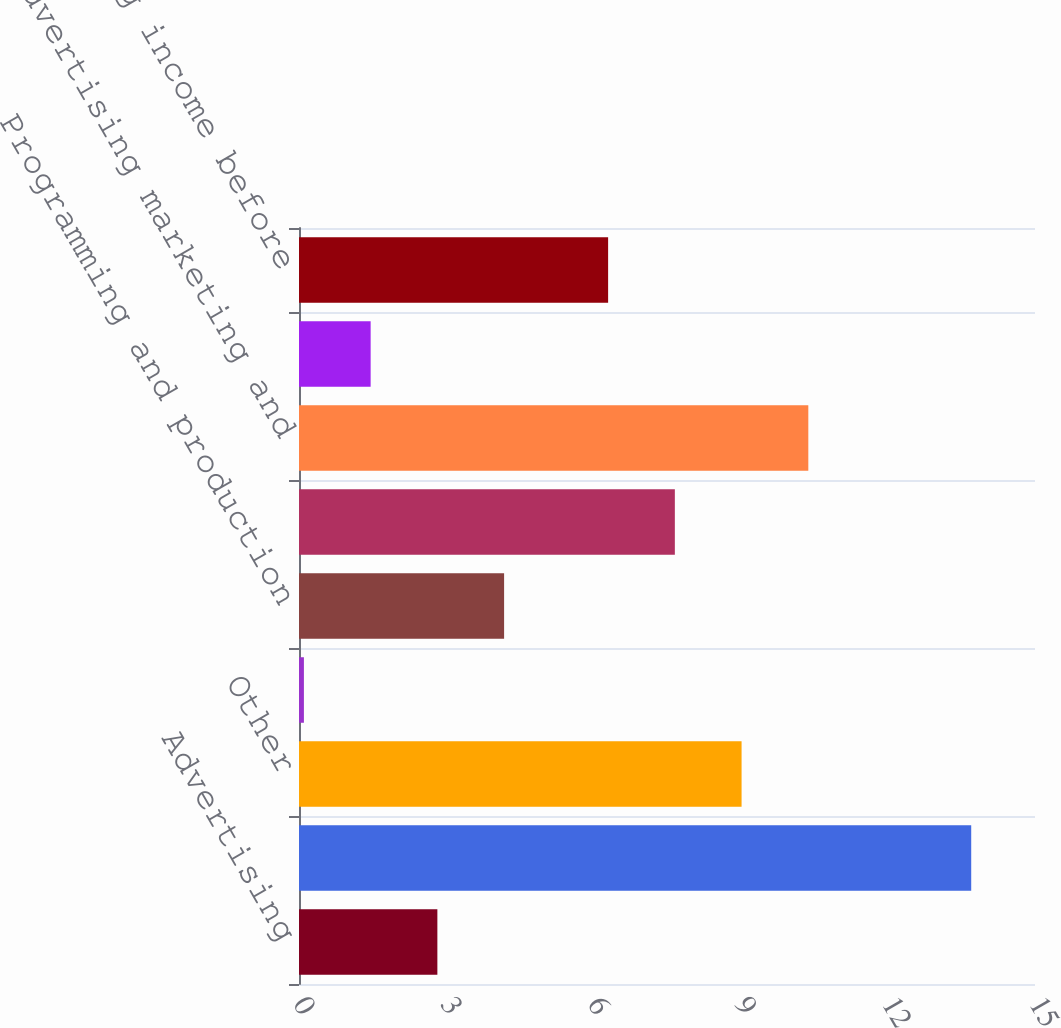Convert chart to OTSL. <chart><loc_0><loc_0><loc_500><loc_500><bar_chart><fcel>Advertising<fcel>Content licensing<fcel>Other<fcel>Total revenue<fcel>Programming and production<fcel>Other operating and<fcel>Advertising marketing and<fcel>Total operating costs and<fcel>Operating income before<nl><fcel>2.82<fcel>13.7<fcel>9.02<fcel>0.1<fcel>4.18<fcel>7.66<fcel>10.38<fcel>1.46<fcel>6.3<nl></chart> 